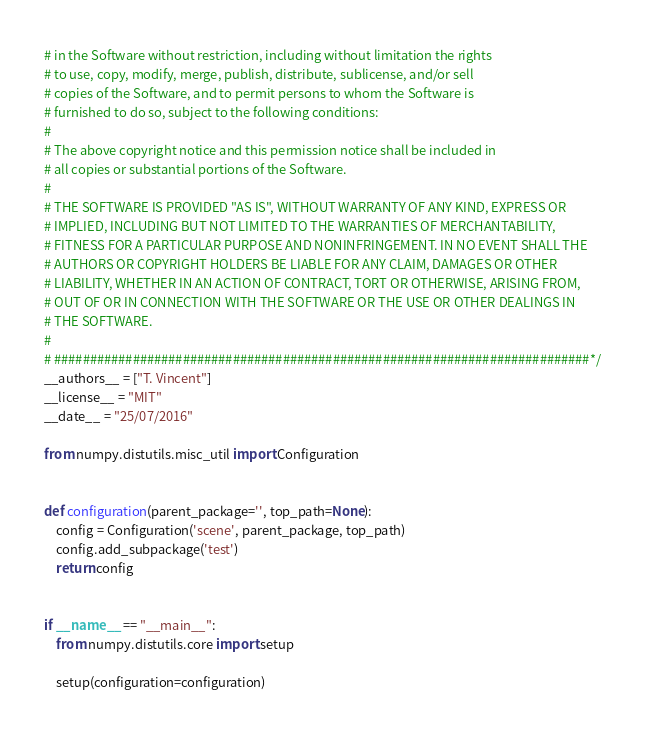<code> <loc_0><loc_0><loc_500><loc_500><_Python_># in the Software without restriction, including without limitation the rights
# to use, copy, modify, merge, publish, distribute, sublicense, and/or sell
# copies of the Software, and to permit persons to whom the Software is
# furnished to do so, subject to the following conditions:
#
# The above copyright notice and this permission notice shall be included in
# all copies or substantial portions of the Software.
#
# THE SOFTWARE IS PROVIDED "AS IS", WITHOUT WARRANTY OF ANY KIND, EXPRESS OR
# IMPLIED, INCLUDING BUT NOT LIMITED TO THE WARRANTIES OF MERCHANTABILITY,
# FITNESS FOR A PARTICULAR PURPOSE AND NONINFRINGEMENT. IN NO EVENT SHALL THE
# AUTHORS OR COPYRIGHT HOLDERS BE LIABLE FOR ANY CLAIM, DAMAGES OR OTHER
# LIABILITY, WHETHER IN AN ACTION OF CONTRACT, TORT OR OTHERWISE, ARISING FROM,
# OUT OF OR IN CONNECTION WITH THE SOFTWARE OR THE USE OR OTHER DEALINGS IN
# THE SOFTWARE.
#
# ###########################################################################*/
__authors__ = ["T. Vincent"]
__license__ = "MIT"
__date__ = "25/07/2016"

from numpy.distutils.misc_util import Configuration


def configuration(parent_package='', top_path=None):
    config = Configuration('scene', parent_package, top_path)
    config.add_subpackage('test')
    return config


if __name__ == "__main__":
    from numpy.distutils.core import setup

    setup(configuration=configuration)
</code> 